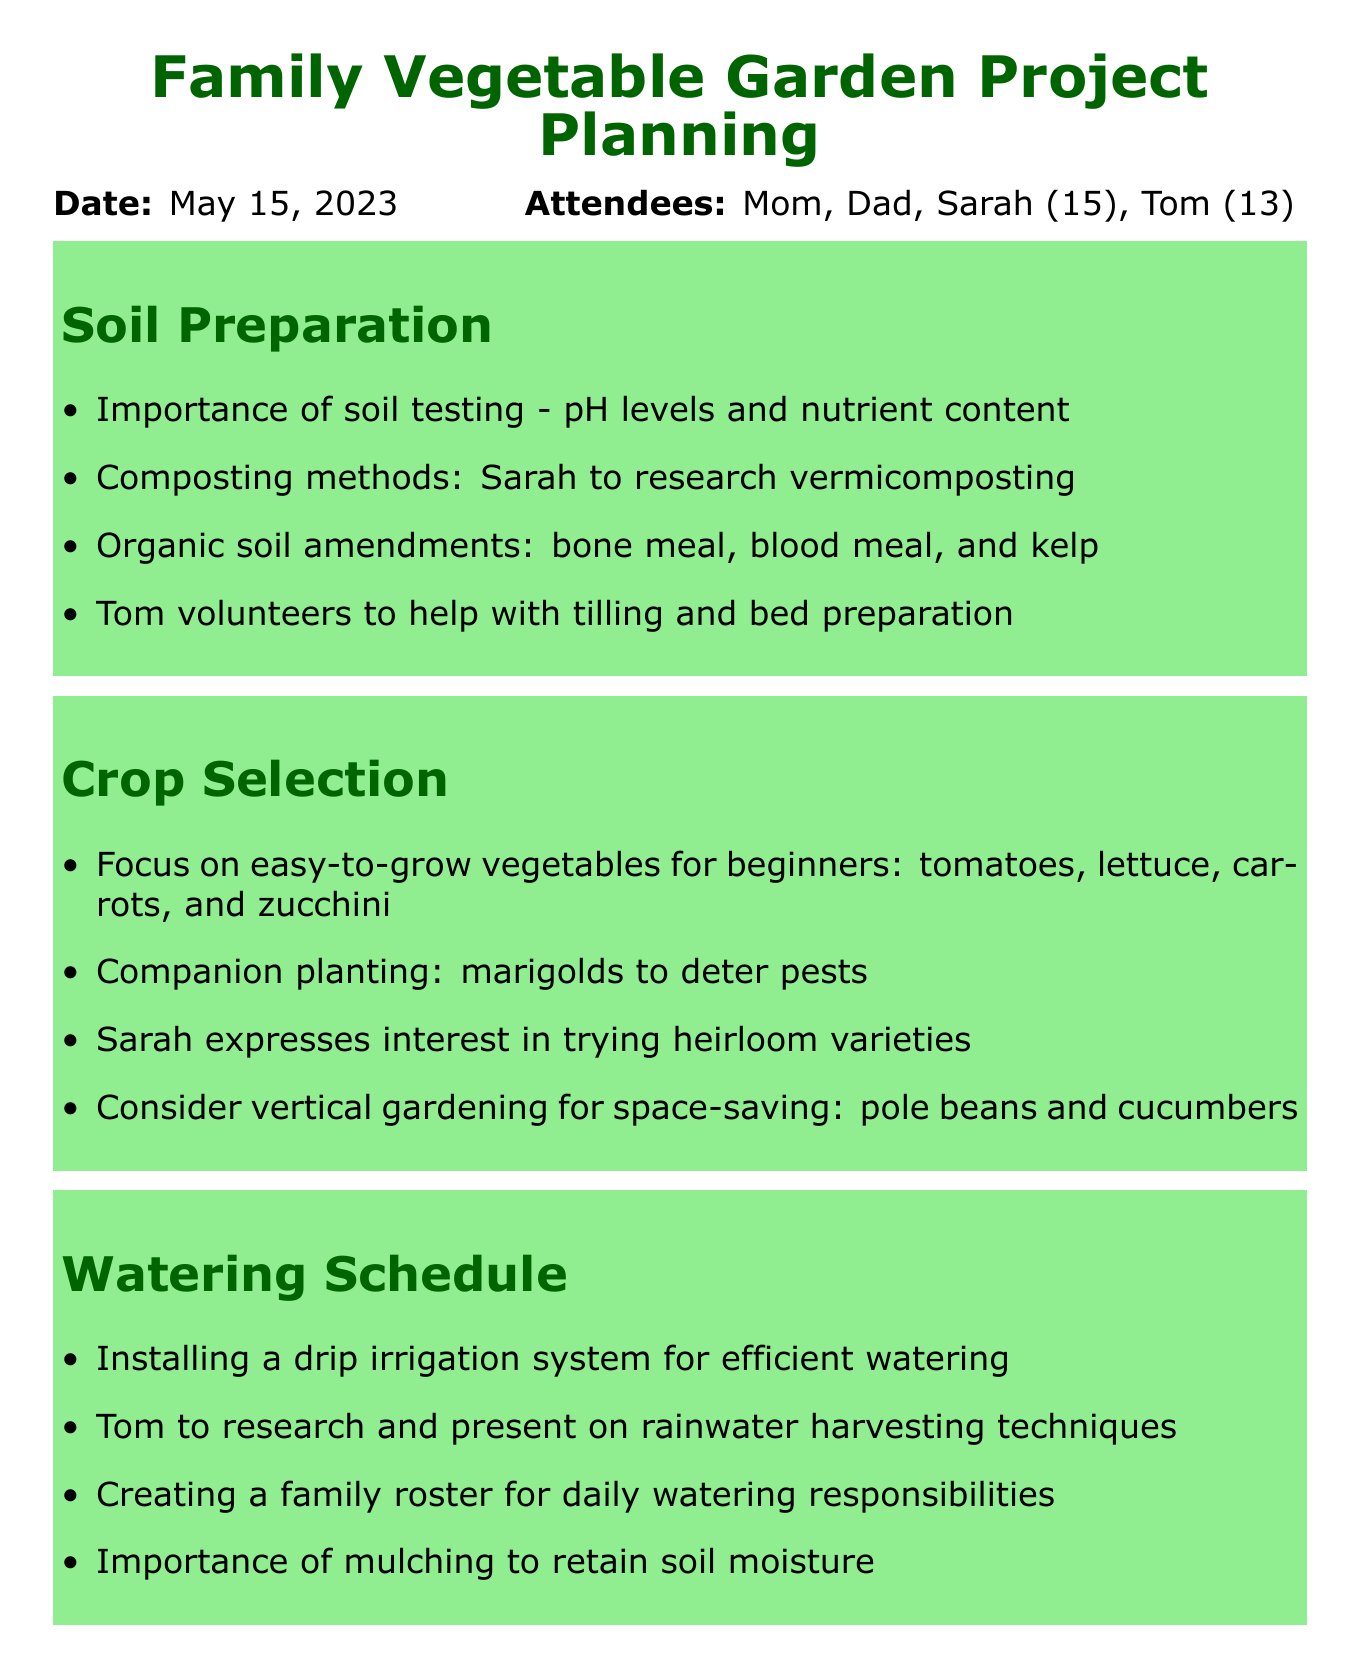What is the date of the meeting? The date of the meeting is specifically mentioned in the document.
Answer: May 15, 2023 Who researched vermicomposting? The document lists Sarah as the person responsible for researching this topic.
Answer: Sarah What type of vegetables were suggested for beginners? Easy-to-grow vegetables for beginners listed in the document include specific types of vegetables.
Answer: tomatoes, lettuce, carrots, and zucchini What system is proposed for watering the garden? The document mentions a specific method for efficient watering.
Answer: drip irrigation system Who volunteered to help with bed preparation? The document states one attendee volunteered for this task.
Answer: Tom What is the family planning to visit for plant selection? The document specifies a location for plant selection.
Answer: Sunshine Garden Center What is mentioned as the importance for soil moisture? The document discusses a technique to retain soil moisture.
Answer: mulching What action item involves investigating rainwater harvesting? The document assigns this research task to one specific family member.
Answer: Tom 